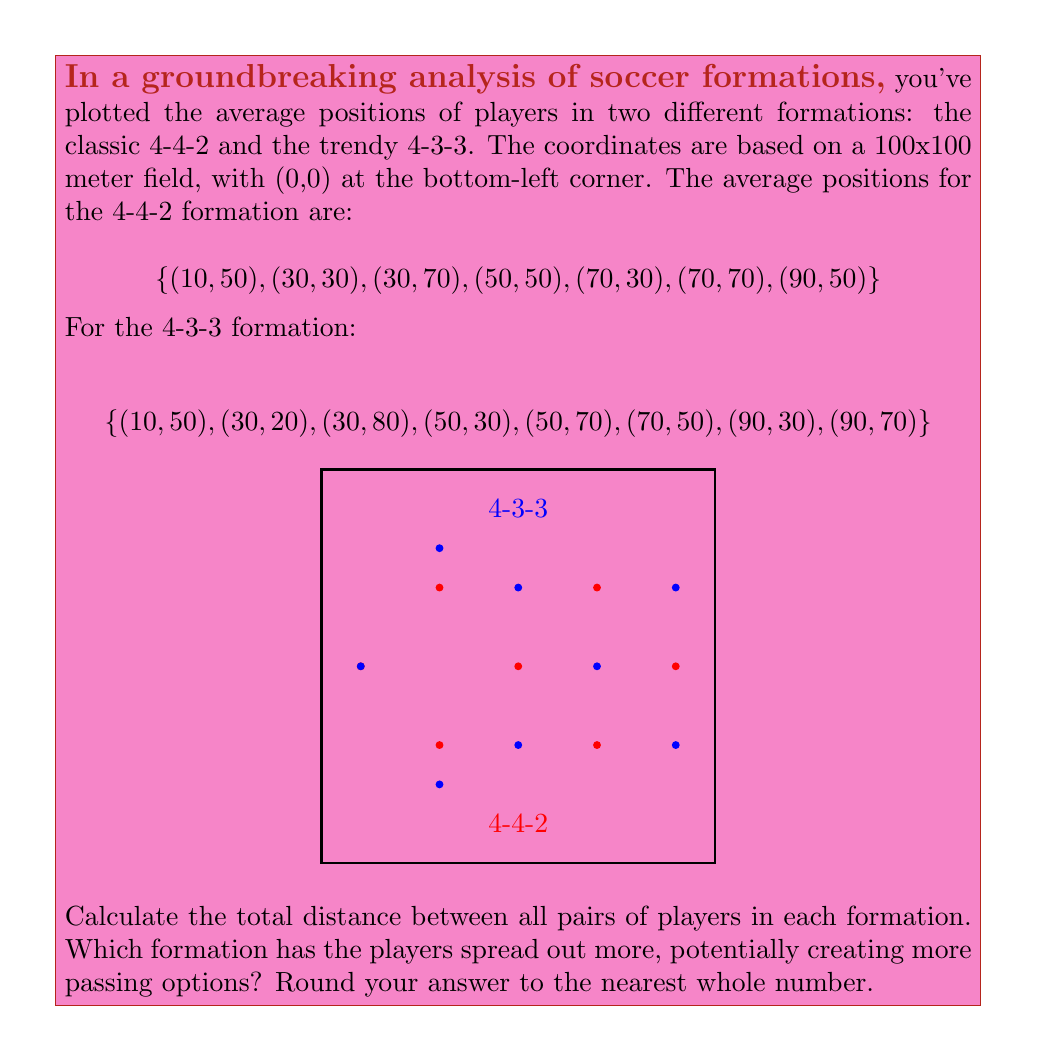Teach me how to tackle this problem. To solve this problem, we need to calculate the total distance between all pairs of players in each formation and compare the results. We'll use the distance formula between two points: 

$$d = \sqrt{(x_2-x_1)^2 + (y_2-y_1)^2}$$

1. For the 4-4-2 formation:
   We have 7 players, so we need to calculate distances for $\binom{7}{2} = 21$ pairs.

2. For the 4-3-3 formation:
   We have 8 players, so we need to calculate distances for $\binom{8}{2} = 28$ pairs.

3. Let's calculate the sum of distances for 4-4-2:
   $$(10,50) \text{ to } (30,30): \sqrt{20^2 + 20^2} = 28.28$$
   $$(10,50) \text{ to } (30,70): \sqrt{20^2 + 20^2} = 28.28$$
   ... (calculating all 21 pairs)
   
   Total sum for 4-4-2: 1160.36

4. Now for 4-3-3:
   $$(10,50) \text{ to } (30,20): \sqrt{20^2 + 30^2} = 36.06$$
   $$(10,50) \text{ to } (30,80): \sqrt{20^2 + 30^2} = 36.06$$
   ... (calculating all 28 pairs)
   
   Total sum for 4-3-3: 1598.28

5. Comparing the results:
   4-4-2: 1160.36
   4-3-3: 1598.28

6. The 4-3-3 formation has a higher total distance, indicating that players are more spread out.

7. Rounding to the nearest whole number:
   4-4-2: 1160
   4-3-3: 1598
Answer: 4-3-3 (1598 vs 1160) 